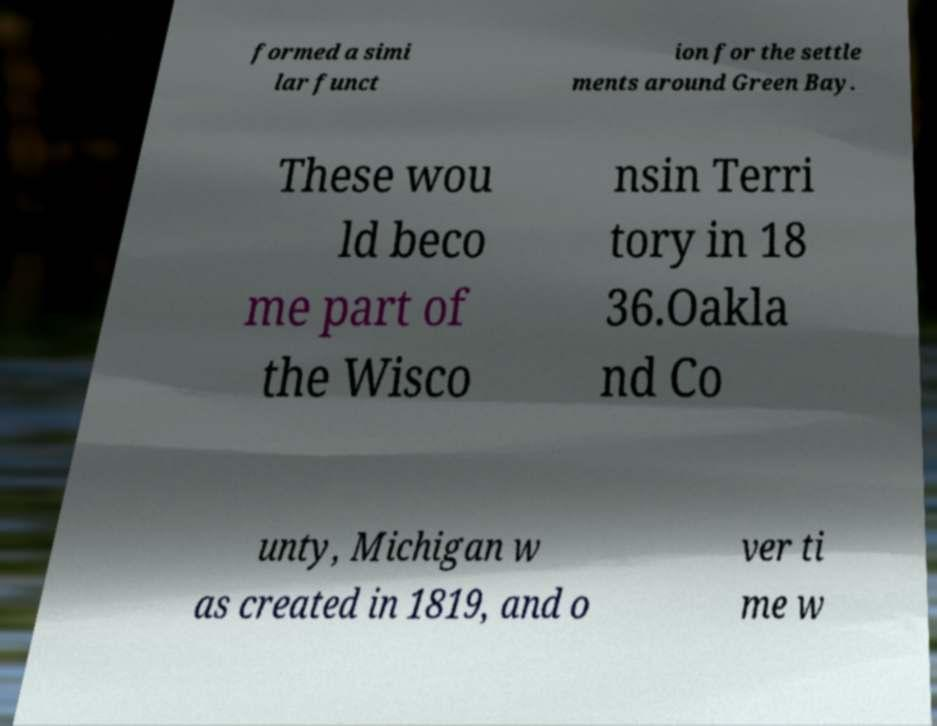Could you extract and type out the text from this image? formed a simi lar funct ion for the settle ments around Green Bay. These wou ld beco me part of the Wisco nsin Terri tory in 18 36.Oakla nd Co unty, Michigan w as created in 1819, and o ver ti me w 